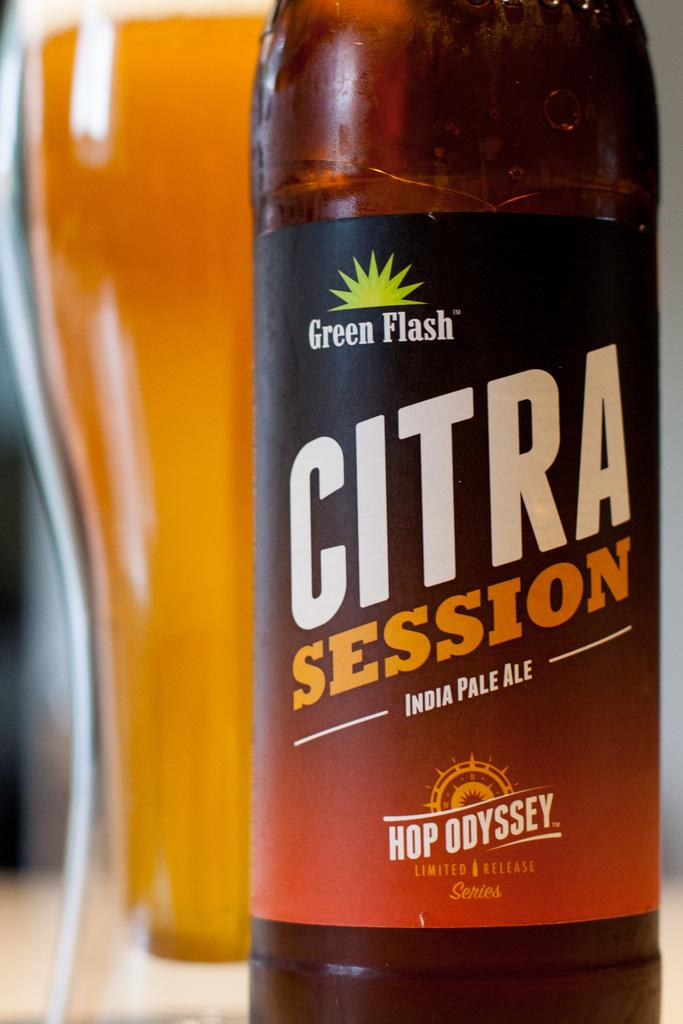<image>
Relay a brief, clear account of the picture shown. A  bottled Citra Session IPA by Green Flash is in front of a glass. 